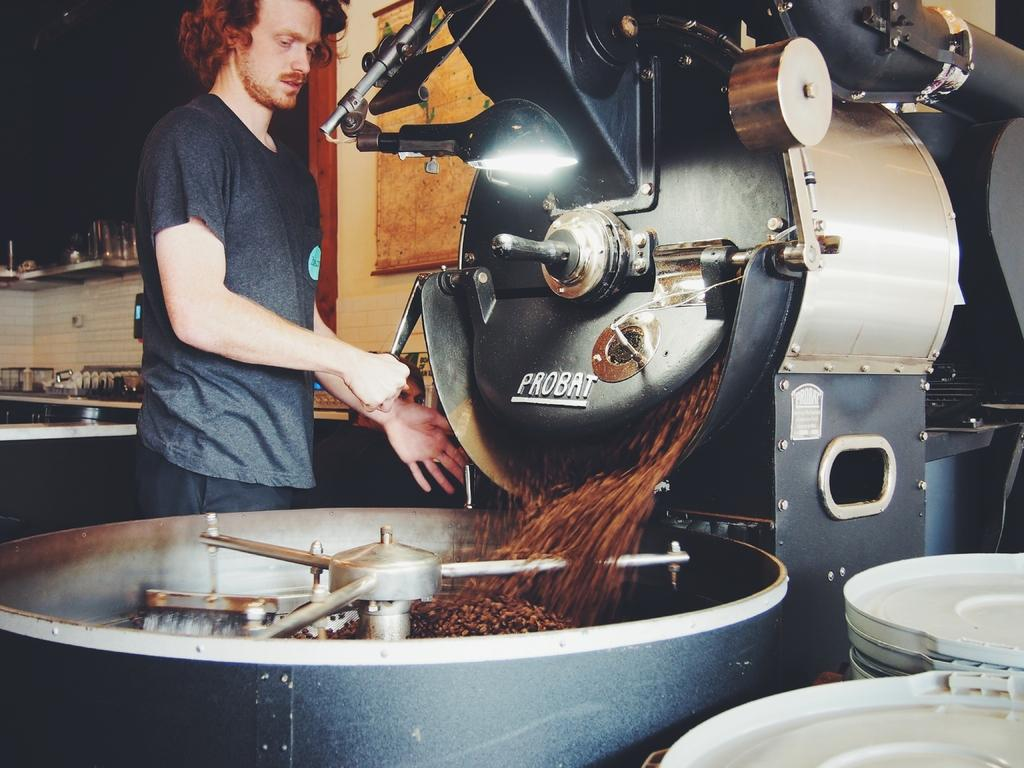What is the man in the image doing? The man is standing in the image and holding a tool. What can be seen in the image besides the man? There is a machine and objects in the image. Can you describe the objects in the background? There are objects on a surface in the background and glasses on a shelf. How does the man attempt to stitch the machine in the image? The image does not show the man attempting to stitch the machine, nor is there any indication that stitching is involved. 